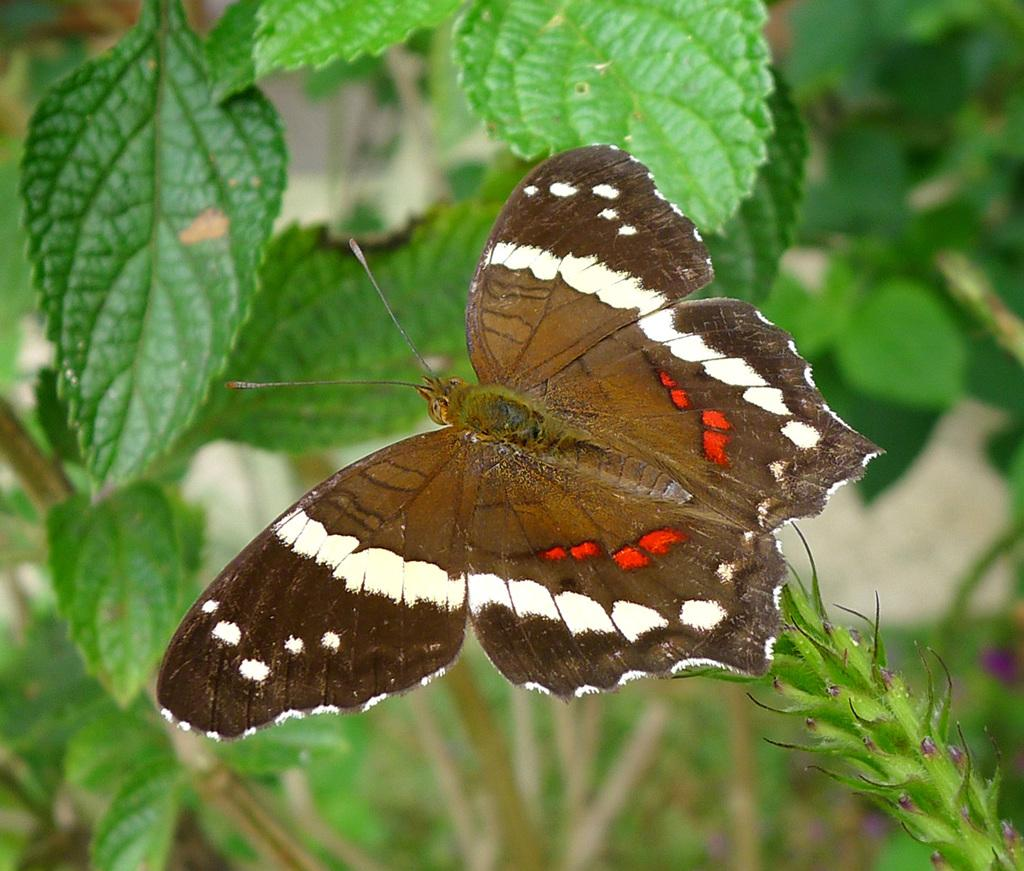What type of animal can be seen in the image? There is a butterfly in the image. What else is present in the image besides the butterfly? There are plants in the image. Can you describe the background of the image? The background of the image is blurry. Where is the maid located in the image? There is no maid present in the image. What channel is the butterfly flying on in the image? The butterfly is not flying on a channel; it is in an image. 